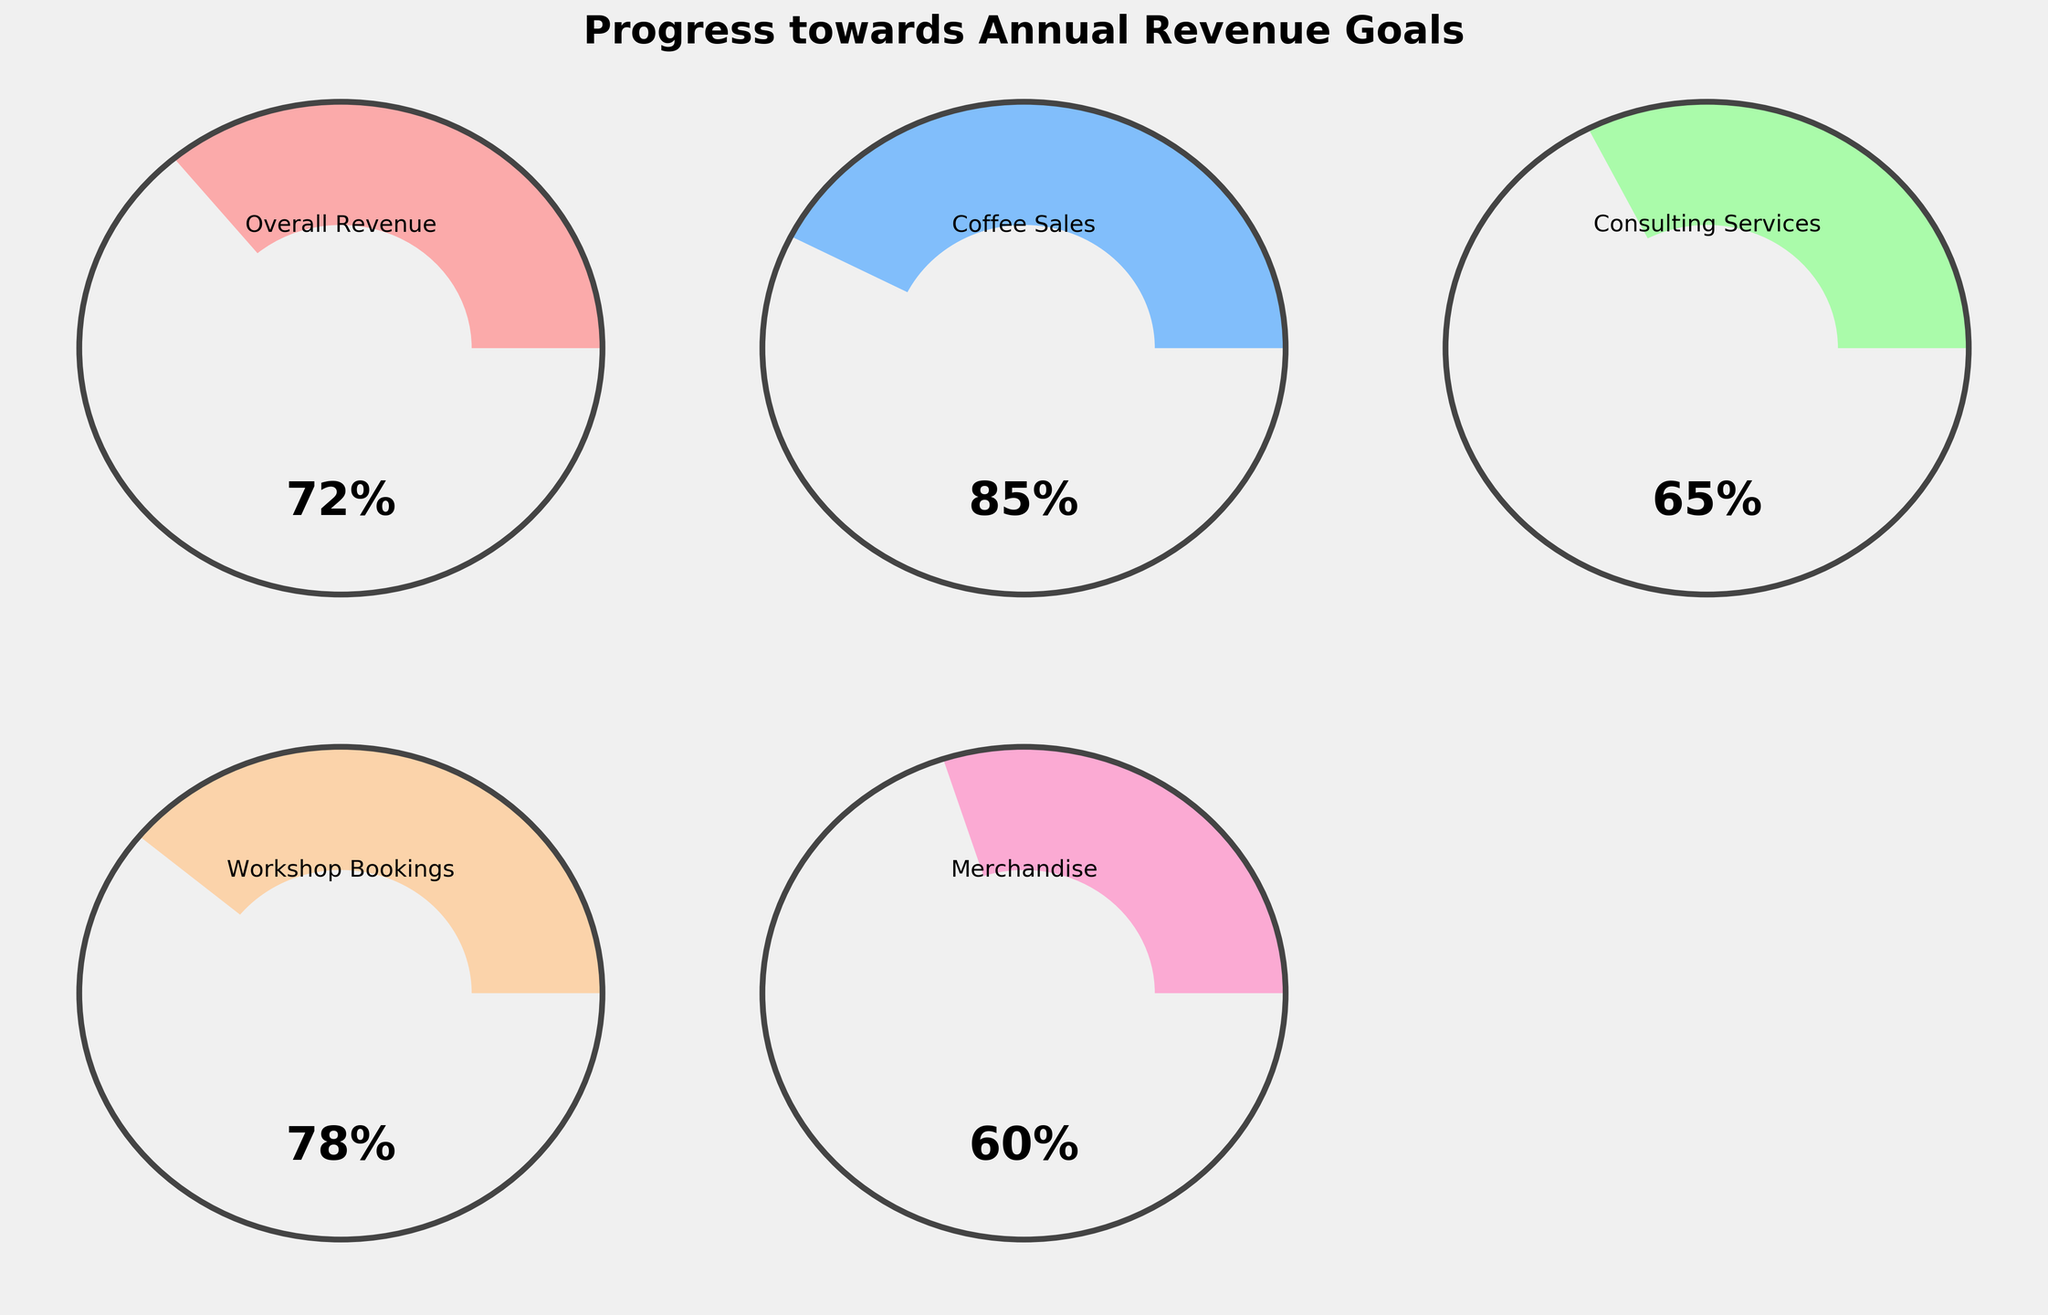What is the title of the figure? The title is usually prominently displayed at the top of the chart. Here, the title "Progress towards Annual Revenue Goals" is shown at the top of the figure in bold, large font.
Answer: Progress towards Annual Revenue Goals How many categories of revenue are displayed in the gauge charts? The figure contains one gauge chart per category shown. By counting the gauges, we can see that there are five categories displayed.
Answer: Five Which category has the highest progress percentage? By observing the text inside the gauge charts, we can see the percentage values. The category with the highest percentage is "Coffee Sales" at 85%.
Answer: Coffee Sales Which category has the lowest progress percentage? Again, by checking the percentage values in the gauges, the "Merchandise" category has the lowest percentage at 60%.
Answer: Merchandise What's the average progress percentage across all categories? To find the average, sum all the progress percentages: 72 + 85 + 65 + 78 + 60 = 360. Then divide by the number of categories (5). So, 360 / 5 = 72.
Answer: 72 Which categories have a progress percentage above 75%? By observing the values inside each gauge chart, we can identify the categories with percentages above 75%. They are "Overall Revenue" (72%, below 75%), "Coffee Sales" (85%), "Consulting Services" (65%, below 75%), "Workshop Bookings" (78%), and "Merchandise" (60%, below 75%). Only "Coffee Sales" and "Workshop Bookings" are above 75%.
Answer: Coffee Sales, Workshop Bookings How many categories are at or above 70% progress? Checking the percentages, the categories "Overall Revenue" (72%), "Coffee Sales" (85%), "Workshop Bookings" (78%) fall at or above 70%.
Answer: 3 What is the total progress percentage when combining "Consulting Services" and "Workshop Bookings"? Summing the progress percentages of these two categories: 65 (Consulting Services) + 78 (Workshop Bookings) = 143.
Answer: 143 If the business sets a goal to have all categories at least at 65%, how many categories have met this goal? Observing each percentage and counting those that are 65% or higher: "Overall Revenue" (72%), "Coffee Sales" (85%), "Consulting Services" (65%), and "Workshop Bookings" (78%) meet this goal.
Answer: 4 